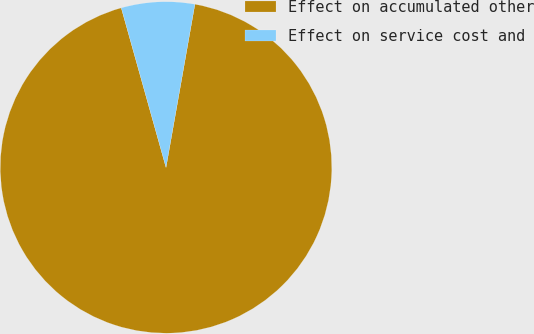Convert chart. <chart><loc_0><loc_0><loc_500><loc_500><pie_chart><fcel>Effect on accumulated other<fcel>Effect on service cost and<nl><fcel>92.86%<fcel>7.14%<nl></chart> 